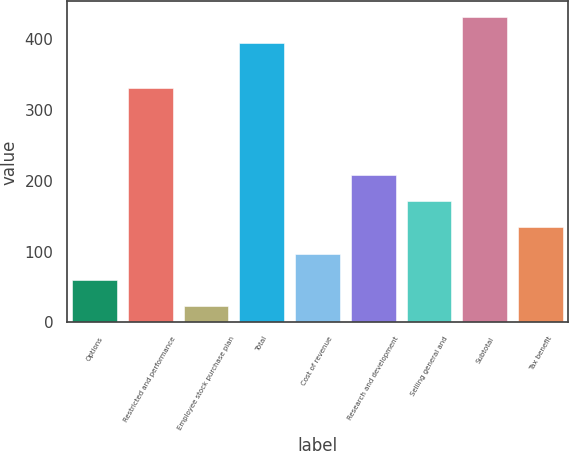<chart> <loc_0><loc_0><loc_500><loc_500><bar_chart><fcel>Options<fcel>Restricted and performance<fcel>Employee stock purchase plan<fcel>Total<fcel>Cost of revenue<fcel>Research and development<fcel>Selling general and<fcel>Subtotal<fcel>Tax benefit<nl><fcel>60.1<fcel>330<fcel>23<fcel>394<fcel>97.2<fcel>208.5<fcel>171.4<fcel>431.1<fcel>134.3<nl></chart> 